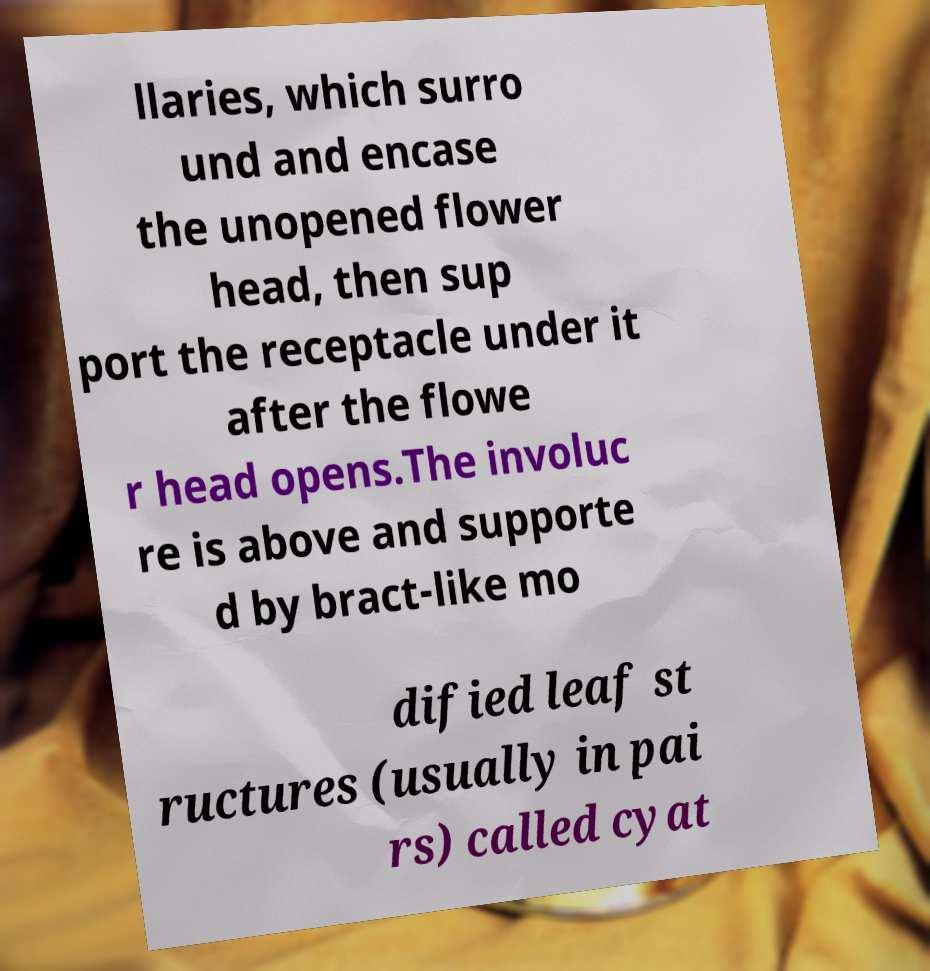Please read and relay the text visible in this image. What does it say? llaries, which surro und and encase the unopened flower head, then sup port the receptacle under it after the flowe r head opens.The involuc re is above and supporte d by bract-like mo dified leaf st ructures (usually in pai rs) called cyat 